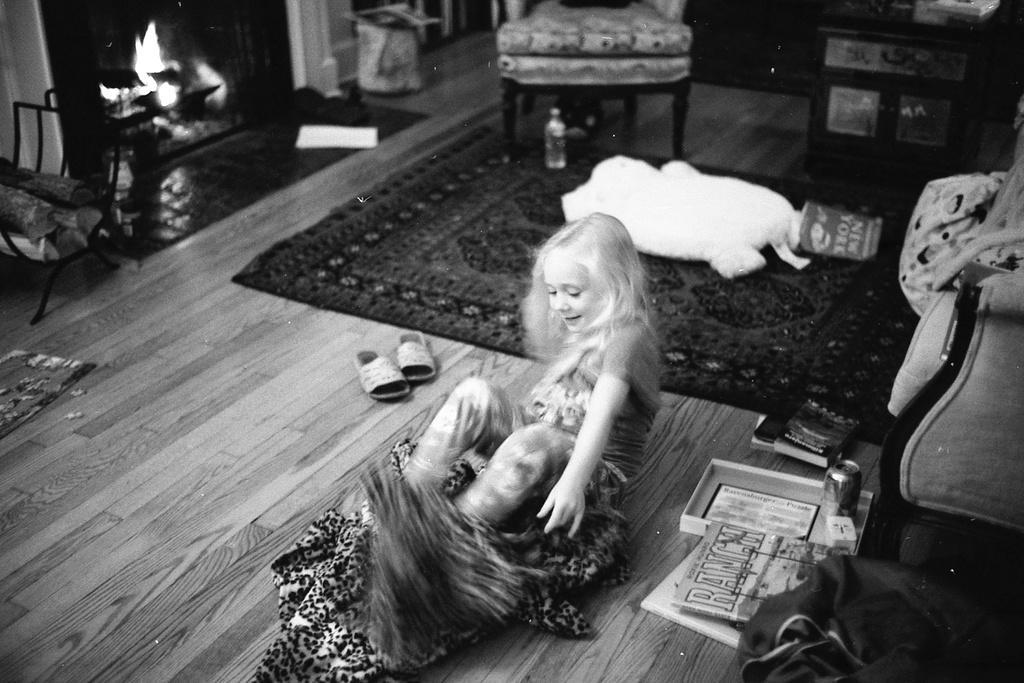Can you describe this image briefly? In this picture I can see a girl, there are books, sandals, tin, box, paper, toy, carpet, bottle, there are chairs, fireplace and some other items. 